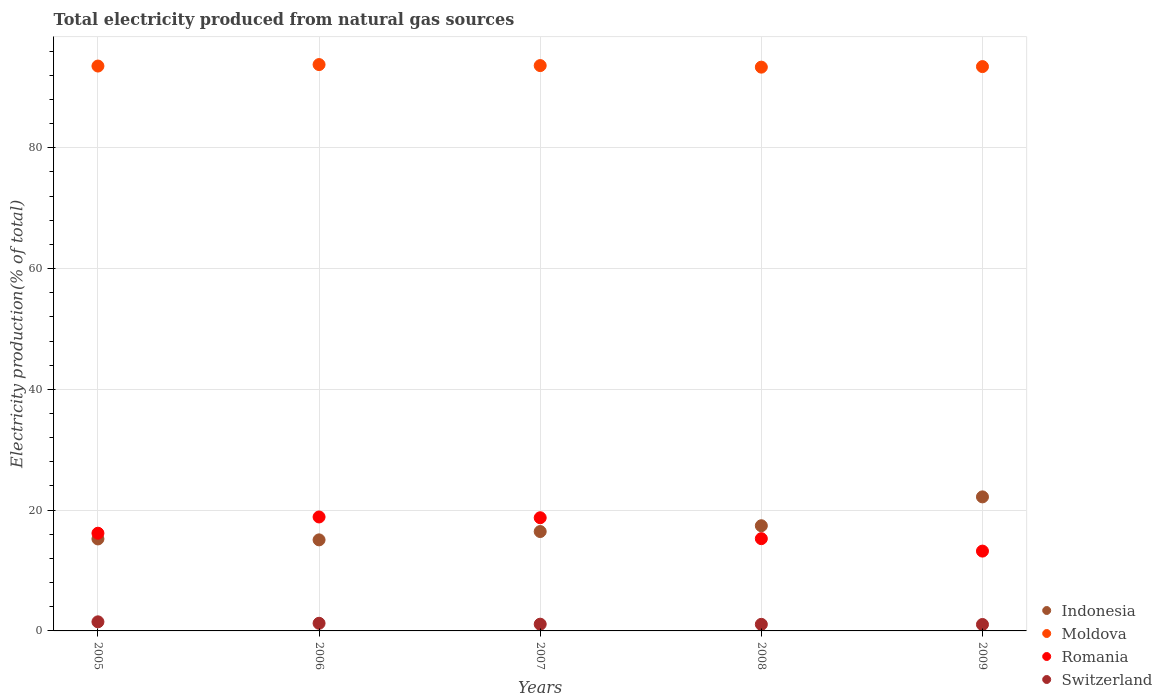What is the total electricity produced in Indonesia in 2005?
Keep it short and to the point. 15.23. Across all years, what is the maximum total electricity produced in Indonesia?
Keep it short and to the point. 22.2. Across all years, what is the minimum total electricity produced in Moldova?
Offer a terse response. 93.36. What is the total total electricity produced in Moldova in the graph?
Give a very brief answer. 467.75. What is the difference between the total electricity produced in Moldova in 2007 and that in 2009?
Ensure brevity in your answer.  0.17. What is the difference between the total electricity produced in Indonesia in 2009 and the total electricity produced in Switzerland in 2007?
Ensure brevity in your answer.  21.08. What is the average total electricity produced in Moldova per year?
Keep it short and to the point. 93.55. In the year 2007, what is the difference between the total electricity produced in Indonesia and total electricity produced in Romania?
Make the answer very short. -2.29. What is the ratio of the total electricity produced in Romania in 2005 to that in 2008?
Provide a succinct answer. 1.06. Is the total electricity produced in Indonesia in 2006 less than that in 2009?
Ensure brevity in your answer.  Yes. Is the difference between the total electricity produced in Indonesia in 2005 and 2007 greater than the difference between the total electricity produced in Romania in 2005 and 2007?
Offer a terse response. Yes. What is the difference between the highest and the second highest total electricity produced in Indonesia?
Offer a very short reply. 4.78. What is the difference between the highest and the lowest total electricity produced in Switzerland?
Your answer should be very brief. 0.44. In how many years, is the total electricity produced in Romania greater than the average total electricity produced in Romania taken over all years?
Provide a short and direct response. 2. Is the sum of the total electricity produced in Moldova in 2005 and 2007 greater than the maximum total electricity produced in Switzerland across all years?
Provide a succinct answer. Yes. Is it the case that in every year, the sum of the total electricity produced in Romania and total electricity produced in Indonesia  is greater than the sum of total electricity produced in Switzerland and total electricity produced in Moldova?
Keep it short and to the point. No. Does the total electricity produced in Romania monotonically increase over the years?
Your answer should be compact. No. Is the total electricity produced in Indonesia strictly greater than the total electricity produced in Moldova over the years?
Offer a terse response. No. How many years are there in the graph?
Give a very brief answer. 5. What is the difference between two consecutive major ticks on the Y-axis?
Provide a succinct answer. 20. Are the values on the major ticks of Y-axis written in scientific E-notation?
Offer a terse response. No. How many legend labels are there?
Offer a very short reply. 4. What is the title of the graph?
Your answer should be compact. Total electricity produced from natural gas sources. What is the Electricity production(% of total) in Indonesia in 2005?
Your answer should be compact. 15.23. What is the Electricity production(% of total) of Moldova in 2005?
Provide a short and direct response. 93.54. What is the Electricity production(% of total) of Romania in 2005?
Your response must be concise. 16.18. What is the Electricity production(% of total) in Switzerland in 2005?
Ensure brevity in your answer.  1.51. What is the Electricity production(% of total) in Indonesia in 2006?
Provide a short and direct response. 15.08. What is the Electricity production(% of total) in Moldova in 2006?
Your answer should be very brief. 93.78. What is the Electricity production(% of total) in Romania in 2006?
Your response must be concise. 18.87. What is the Electricity production(% of total) in Switzerland in 2006?
Ensure brevity in your answer.  1.26. What is the Electricity production(% of total) in Indonesia in 2007?
Make the answer very short. 16.46. What is the Electricity production(% of total) in Moldova in 2007?
Your answer should be very brief. 93.62. What is the Electricity production(% of total) of Romania in 2007?
Your response must be concise. 18.74. What is the Electricity production(% of total) of Switzerland in 2007?
Offer a very short reply. 1.12. What is the Electricity production(% of total) in Indonesia in 2008?
Provide a short and direct response. 17.42. What is the Electricity production(% of total) in Moldova in 2008?
Give a very brief answer. 93.36. What is the Electricity production(% of total) in Romania in 2008?
Your answer should be compact. 15.28. What is the Electricity production(% of total) in Switzerland in 2008?
Provide a short and direct response. 1.09. What is the Electricity production(% of total) in Indonesia in 2009?
Ensure brevity in your answer.  22.2. What is the Electricity production(% of total) of Moldova in 2009?
Give a very brief answer. 93.45. What is the Electricity production(% of total) in Romania in 2009?
Your response must be concise. 13.22. What is the Electricity production(% of total) of Switzerland in 2009?
Give a very brief answer. 1.06. Across all years, what is the maximum Electricity production(% of total) in Indonesia?
Your answer should be very brief. 22.2. Across all years, what is the maximum Electricity production(% of total) of Moldova?
Provide a succinct answer. 93.78. Across all years, what is the maximum Electricity production(% of total) of Romania?
Offer a terse response. 18.87. Across all years, what is the maximum Electricity production(% of total) in Switzerland?
Your response must be concise. 1.51. Across all years, what is the minimum Electricity production(% of total) of Indonesia?
Provide a short and direct response. 15.08. Across all years, what is the minimum Electricity production(% of total) in Moldova?
Offer a very short reply. 93.36. Across all years, what is the minimum Electricity production(% of total) of Romania?
Provide a short and direct response. 13.22. Across all years, what is the minimum Electricity production(% of total) in Switzerland?
Offer a terse response. 1.06. What is the total Electricity production(% of total) of Indonesia in the graph?
Your answer should be very brief. 86.38. What is the total Electricity production(% of total) in Moldova in the graph?
Provide a short and direct response. 467.75. What is the total Electricity production(% of total) in Romania in the graph?
Make the answer very short. 82.29. What is the total Electricity production(% of total) in Switzerland in the graph?
Offer a very short reply. 6.04. What is the difference between the Electricity production(% of total) in Indonesia in 2005 and that in 2006?
Your answer should be compact. 0.16. What is the difference between the Electricity production(% of total) of Moldova in 2005 and that in 2006?
Keep it short and to the point. -0.24. What is the difference between the Electricity production(% of total) in Romania in 2005 and that in 2006?
Offer a terse response. -2.69. What is the difference between the Electricity production(% of total) of Switzerland in 2005 and that in 2006?
Your response must be concise. 0.24. What is the difference between the Electricity production(% of total) in Indonesia in 2005 and that in 2007?
Your answer should be very brief. -1.22. What is the difference between the Electricity production(% of total) of Moldova in 2005 and that in 2007?
Provide a short and direct response. -0.08. What is the difference between the Electricity production(% of total) of Romania in 2005 and that in 2007?
Offer a very short reply. -2.56. What is the difference between the Electricity production(% of total) in Switzerland in 2005 and that in 2007?
Your answer should be very brief. 0.39. What is the difference between the Electricity production(% of total) in Indonesia in 2005 and that in 2008?
Make the answer very short. -2.18. What is the difference between the Electricity production(% of total) of Moldova in 2005 and that in 2008?
Offer a very short reply. 0.18. What is the difference between the Electricity production(% of total) of Romania in 2005 and that in 2008?
Keep it short and to the point. 0.9. What is the difference between the Electricity production(% of total) of Switzerland in 2005 and that in 2008?
Provide a succinct answer. 0.42. What is the difference between the Electricity production(% of total) in Indonesia in 2005 and that in 2009?
Provide a succinct answer. -6.96. What is the difference between the Electricity production(% of total) in Moldova in 2005 and that in 2009?
Your answer should be very brief. 0.09. What is the difference between the Electricity production(% of total) in Romania in 2005 and that in 2009?
Offer a very short reply. 2.96. What is the difference between the Electricity production(% of total) in Switzerland in 2005 and that in 2009?
Make the answer very short. 0.44. What is the difference between the Electricity production(% of total) in Indonesia in 2006 and that in 2007?
Provide a short and direct response. -1.38. What is the difference between the Electricity production(% of total) of Moldova in 2006 and that in 2007?
Your answer should be compact. 0.17. What is the difference between the Electricity production(% of total) in Romania in 2006 and that in 2007?
Provide a short and direct response. 0.13. What is the difference between the Electricity production(% of total) of Switzerland in 2006 and that in 2007?
Provide a short and direct response. 0.15. What is the difference between the Electricity production(% of total) of Indonesia in 2006 and that in 2008?
Make the answer very short. -2.34. What is the difference between the Electricity production(% of total) of Moldova in 2006 and that in 2008?
Keep it short and to the point. 0.43. What is the difference between the Electricity production(% of total) in Romania in 2006 and that in 2008?
Offer a terse response. 3.59. What is the difference between the Electricity production(% of total) of Switzerland in 2006 and that in 2008?
Keep it short and to the point. 0.17. What is the difference between the Electricity production(% of total) of Indonesia in 2006 and that in 2009?
Your answer should be very brief. -7.12. What is the difference between the Electricity production(% of total) in Moldova in 2006 and that in 2009?
Make the answer very short. 0.33. What is the difference between the Electricity production(% of total) of Romania in 2006 and that in 2009?
Your answer should be compact. 5.65. What is the difference between the Electricity production(% of total) of Switzerland in 2006 and that in 2009?
Your response must be concise. 0.2. What is the difference between the Electricity production(% of total) of Indonesia in 2007 and that in 2008?
Your answer should be compact. -0.96. What is the difference between the Electricity production(% of total) of Moldova in 2007 and that in 2008?
Your answer should be very brief. 0.26. What is the difference between the Electricity production(% of total) in Romania in 2007 and that in 2008?
Ensure brevity in your answer.  3.46. What is the difference between the Electricity production(% of total) in Switzerland in 2007 and that in 2008?
Your response must be concise. 0.03. What is the difference between the Electricity production(% of total) of Indonesia in 2007 and that in 2009?
Make the answer very short. -5.74. What is the difference between the Electricity production(% of total) in Moldova in 2007 and that in 2009?
Provide a short and direct response. 0.17. What is the difference between the Electricity production(% of total) of Romania in 2007 and that in 2009?
Provide a short and direct response. 5.52. What is the difference between the Electricity production(% of total) in Switzerland in 2007 and that in 2009?
Your answer should be very brief. 0.05. What is the difference between the Electricity production(% of total) in Indonesia in 2008 and that in 2009?
Offer a terse response. -4.78. What is the difference between the Electricity production(% of total) in Moldova in 2008 and that in 2009?
Offer a terse response. -0.09. What is the difference between the Electricity production(% of total) in Romania in 2008 and that in 2009?
Offer a terse response. 2.06. What is the difference between the Electricity production(% of total) in Switzerland in 2008 and that in 2009?
Give a very brief answer. 0.02. What is the difference between the Electricity production(% of total) in Indonesia in 2005 and the Electricity production(% of total) in Moldova in 2006?
Your response must be concise. -78.55. What is the difference between the Electricity production(% of total) in Indonesia in 2005 and the Electricity production(% of total) in Romania in 2006?
Your response must be concise. -3.64. What is the difference between the Electricity production(% of total) in Indonesia in 2005 and the Electricity production(% of total) in Switzerland in 2006?
Your response must be concise. 13.97. What is the difference between the Electricity production(% of total) of Moldova in 2005 and the Electricity production(% of total) of Romania in 2006?
Offer a terse response. 74.67. What is the difference between the Electricity production(% of total) of Moldova in 2005 and the Electricity production(% of total) of Switzerland in 2006?
Ensure brevity in your answer.  92.28. What is the difference between the Electricity production(% of total) of Romania in 2005 and the Electricity production(% of total) of Switzerland in 2006?
Ensure brevity in your answer.  14.91. What is the difference between the Electricity production(% of total) in Indonesia in 2005 and the Electricity production(% of total) in Moldova in 2007?
Your answer should be very brief. -78.38. What is the difference between the Electricity production(% of total) in Indonesia in 2005 and the Electricity production(% of total) in Romania in 2007?
Offer a very short reply. -3.51. What is the difference between the Electricity production(% of total) in Indonesia in 2005 and the Electricity production(% of total) in Switzerland in 2007?
Offer a terse response. 14.12. What is the difference between the Electricity production(% of total) of Moldova in 2005 and the Electricity production(% of total) of Romania in 2007?
Your answer should be compact. 74.8. What is the difference between the Electricity production(% of total) of Moldova in 2005 and the Electricity production(% of total) of Switzerland in 2007?
Offer a terse response. 92.42. What is the difference between the Electricity production(% of total) in Romania in 2005 and the Electricity production(% of total) in Switzerland in 2007?
Keep it short and to the point. 15.06. What is the difference between the Electricity production(% of total) in Indonesia in 2005 and the Electricity production(% of total) in Moldova in 2008?
Keep it short and to the point. -78.12. What is the difference between the Electricity production(% of total) in Indonesia in 2005 and the Electricity production(% of total) in Romania in 2008?
Your answer should be compact. -0.05. What is the difference between the Electricity production(% of total) in Indonesia in 2005 and the Electricity production(% of total) in Switzerland in 2008?
Give a very brief answer. 14.14. What is the difference between the Electricity production(% of total) in Moldova in 2005 and the Electricity production(% of total) in Romania in 2008?
Your answer should be compact. 78.26. What is the difference between the Electricity production(% of total) in Moldova in 2005 and the Electricity production(% of total) in Switzerland in 2008?
Keep it short and to the point. 92.45. What is the difference between the Electricity production(% of total) of Romania in 2005 and the Electricity production(% of total) of Switzerland in 2008?
Keep it short and to the point. 15.09. What is the difference between the Electricity production(% of total) in Indonesia in 2005 and the Electricity production(% of total) in Moldova in 2009?
Keep it short and to the point. -78.22. What is the difference between the Electricity production(% of total) in Indonesia in 2005 and the Electricity production(% of total) in Romania in 2009?
Provide a short and direct response. 2.02. What is the difference between the Electricity production(% of total) of Indonesia in 2005 and the Electricity production(% of total) of Switzerland in 2009?
Provide a succinct answer. 14.17. What is the difference between the Electricity production(% of total) in Moldova in 2005 and the Electricity production(% of total) in Romania in 2009?
Provide a short and direct response. 80.32. What is the difference between the Electricity production(% of total) of Moldova in 2005 and the Electricity production(% of total) of Switzerland in 2009?
Offer a terse response. 92.47. What is the difference between the Electricity production(% of total) of Romania in 2005 and the Electricity production(% of total) of Switzerland in 2009?
Offer a terse response. 15.11. What is the difference between the Electricity production(% of total) of Indonesia in 2006 and the Electricity production(% of total) of Moldova in 2007?
Your response must be concise. -78.54. What is the difference between the Electricity production(% of total) in Indonesia in 2006 and the Electricity production(% of total) in Romania in 2007?
Make the answer very short. -3.66. What is the difference between the Electricity production(% of total) of Indonesia in 2006 and the Electricity production(% of total) of Switzerland in 2007?
Offer a terse response. 13.96. What is the difference between the Electricity production(% of total) in Moldova in 2006 and the Electricity production(% of total) in Romania in 2007?
Ensure brevity in your answer.  75.04. What is the difference between the Electricity production(% of total) of Moldova in 2006 and the Electricity production(% of total) of Switzerland in 2007?
Offer a terse response. 92.67. What is the difference between the Electricity production(% of total) of Romania in 2006 and the Electricity production(% of total) of Switzerland in 2007?
Your response must be concise. 17.75. What is the difference between the Electricity production(% of total) in Indonesia in 2006 and the Electricity production(% of total) in Moldova in 2008?
Provide a short and direct response. -78.28. What is the difference between the Electricity production(% of total) in Indonesia in 2006 and the Electricity production(% of total) in Romania in 2008?
Keep it short and to the point. -0.2. What is the difference between the Electricity production(% of total) in Indonesia in 2006 and the Electricity production(% of total) in Switzerland in 2008?
Ensure brevity in your answer.  13.99. What is the difference between the Electricity production(% of total) of Moldova in 2006 and the Electricity production(% of total) of Romania in 2008?
Provide a short and direct response. 78.51. What is the difference between the Electricity production(% of total) in Moldova in 2006 and the Electricity production(% of total) in Switzerland in 2008?
Your answer should be very brief. 92.69. What is the difference between the Electricity production(% of total) in Romania in 2006 and the Electricity production(% of total) in Switzerland in 2008?
Keep it short and to the point. 17.78. What is the difference between the Electricity production(% of total) of Indonesia in 2006 and the Electricity production(% of total) of Moldova in 2009?
Make the answer very short. -78.37. What is the difference between the Electricity production(% of total) of Indonesia in 2006 and the Electricity production(% of total) of Romania in 2009?
Offer a terse response. 1.86. What is the difference between the Electricity production(% of total) of Indonesia in 2006 and the Electricity production(% of total) of Switzerland in 2009?
Provide a short and direct response. 14.01. What is the difference between the Electricity production(% of total) of Moldova in 2006 and the Electricity production(% of total) of Romania in 2009?
Your answer should be very brief. 80.57. What is the difference between the Electricity production(% of total) of Moldova in 2006 and the Electricity production(% of total) of Switzerland in 2009?
Keep it short and to the point. 92.72. What is the difference between the Electricity production(% of total) in Romania in 2006 and the Electricity production(% of total) in Switzerland in 2009?
Make the answer very short. 17.81. What is the difference between the Electricity production(% of total) in Indonesia in 2007 and the Electricity production(% of total) in Moldova in 2008?
Offer a terse response. -76.9. What is the difference between the Electricity production(% of total) in Indonesia in 2007 and the Electricity production(% of total) in Romania in 2008?
Give a very brief answer. 1.18. What is the difference between the Electricity production(% of total) of Indonesia in 2007 and the Electricity production(% of total) of Switzerland in 2008?
Make the answer very short. 15.37. What is the difference between the Electricity production(% of total) of Moldova in 2007 and the Electricity production(% of total) of Romania in 2008?
Make the answer very short. 78.34. What is the difference between the Electricity production(% of total) in Moldova in 2007 and the Electricity production(% of total) in Switzerland in 2008?
Offer a very short reply. 92.53. What is the difference between the Electricity production(% of total) of Romania in 2007 and the Electricity production(% of total) of Switzerland in 2008?
Offer a very short reply. 17.65. What is the difference between the Electricity production(% of total) of Indonesia in 2007 and the Electricity production(% of total) of Moldova in 2009?
Keep it short and to the point. -76.99. What is the difference between the Electricity production(% of total) in Indonesia in 2007 and the Electricity production(% of total) in Romania in 2009?
Offer a terse response. 3.24. What is the difference between the Electricity production(% of total) in Indonesia in 2007 and the Electricity production(% of total) in Switzerland in 2009?
Make the answer very short. 15.39. What is the difference between the Electricity production(% of total) in Moldova in 2007 and the Electricity production(% of total) in Romania in 2009?
Make the answer very short. 80.4. What is the difference between the Electricity production(% of total) in Moldova in 2007 and the Electricity production(% of total) in Switzerland in 2009?
Ensure brevity in your answer.  92.55. What is the difference between the Electricity production(% of total) in Romania in 2007 and the Electricity production(% of total) in Switzerland in 2009?
Give a very brief answer. 17.68. What is the difference between the Electricity production(% of total) of Indonesia in 2008 and the Electricity production(% of total) of Moldova in 2009?
Offer a very short reply. -76.03. What is the difference between the Electricity production(% of total) of Indonesia in 2008 and the Electricity production(% of total) of Romania in 2009?
Provide a succinct answer. 4.2. What is the difference between the Electricity production(% of total) in Indonesia in 2008 and the Electricity production(% of total) in Switzerland in 2009?
Make the answer very short. 16.35. What is the difference between the Electricity production(% of total) in Moldova in 2008 and the Electricity production(% of total) in Romania in 2009?
Offer a terse response. 80.14. What is the difference between the Electricity production(% of total) in Moldova in 2008 and the Electricity production(% of total) in Switzerland in 2009?
Your answer should be very brief. 92.29. What is the difference between the Electricity production(% of total) in Romania in 2008 and the Electricity production(% of total) in Switzerland in 2009?
Give a very brief answer. 14.21. What is the average Electricity production(% of total) in Indonesia per year?
Provide a succinct answer. 17.28. What is the average Electricity production(% of total) in Moldova per year?
Offer a terse response. 93.55. What is the average Electricity production(% of total) of Romania per year?
Make the answer very short. 16.46. What is the average Electricity production(% of total) in Switzerland per year?
Your answer should be very brief. 1.21. In the year 2005, what is the difference between the Electricity production(% of total) of Indonesia and Electricity production(% of total) of Moldova?
Keep it short and to the point. -78.31. In the year 2005, what is the difference between the Electricity production(% of total) of Indonesia and Electricity production(% of total) of Romania?
Your answer should be very brief. -0.95. In the year 2005, what is the difference between the Electricity production(% of total) in Indonesia and Electricity production(% of total) in Switzerland?
Provide a succinct answer. 13.73. In the year 2005, what is the difference between the Electricity production(% of total) of Moldova and Electricity production(% of total) of Romania?
Offer a very short reply. 77.36. In the year 2005, what is the difference between the Electricity production(% of total) of Moldova and Electricity production(% of total) of Switzerland?
Keep it short and to the point. 92.03. In the year 2005, what is the difference between the Electricity production(% of total) of Romania and Electricity production(% of total) of Switzerland?
Ensure brevity in your answer.  14.67. In the year 2006, what is the difference between the Electricity production(% of total) in Indonesia and Electricity production(% of total) in Moldova?
Make the answer very short. -78.71. In the year 2006, what is the difference between the Electricity production(% of total) of Indonesia and Electricity production(% of total) of Romania?
Your response must be concise. -3.79. In the year 2006, what is the difference between the Electricity production(% of total) of Indonesia and Electricity production(% of total) of Switzerland?
Make the answer very short. 13.81. In the year 2006, what is the difference between the Electricity production(% of total) of Moldova and Electricity production(% of total) of Romania?
Provide a short and direct response. 74.91. In the year 2006, what is the difference between the Electricity production(% of total) of Moldova and Electricity production(% of total) of Switzerland?
Offer a terse response. 92.52. In the year 2006, what is the difference between the Electricity production(% of total) in Romania and Electricity production(% of total) in Switzerland?
Offer a very short reply. 17.61. In the year 2007, what is the difference between the Electricity production(% of total) of Indonesia and Electricity production(% of total) of Moldova?
Offer a terse response. -77.16. In the year 2007, what is the difference between the Electricity production(% of total) in Indonesia and Electricity production(% of total) in Romania?
Offer a very short reply. -2.29. In the year 2007, what is the difference between the Electricity production(% of total) in Indonesia and Electricity production(% of total) in Switzerland?
Your answer should be compact. 15.34. In the year 2007, what is the difference between the Electricity production(% of total) in Moldova and Electricity production(% of total) in Romania?
Your answer should be compact. 74.87. In the year 2007, what is the difference between the Electricity production(% of total) of Moldova and Electricity production(% of total) of Switzerland?
Provide a short and direct response. 92.5. In the year 2007, what is the difference between the Electricity production(% of total) in Romania and Electricity production(% of total) in Switzerland?
Provide a succinct answer. 17.63. In the year 2008, what is the difference between the Electricity production(% of total) in Indonesia and Electricity production(% of total) in Moldova?
Your answer should be compact. -75.94. In the year 2008, what is the difference between the Electricity production(% of total) in Indonesia and Electricity production(% of total) in Romania?
Make the answer very short. 2.14. In the year 2008, what is the difference between the Electricity production(% of total) in Indonesia and Electricity production(% of total) in Switzerland?
Ensure brevity in your answer.  16.33. In the year 2008, what is the difference between the Electricity production(% of total) in Moldova and Electricity production(% of total) in Romania?
Provide a succinct answer. 78.08. In the year 2008, what is the difference between the Electricity production(% of total) in Moldova and Electricity production(% of total) in Switzerland?
Offer a terse response. 92.27. In the year 2008, what is the difference between the Electricity production(% of total) of Romania and Electricity production(% of total) of Switzerland?
Provide a succinct answer. 14.19. In the year 2009, what is the difference between the Electricity production(% of total) of Indonesia and Electricity production(% of total) of Moldova?
Your response must be concise. -71.25. In the year 2009, what is the difference between the Electricity production(% of total) of Indonesia and Electricity production(% of total) of Romania?
Your response must be concise. 8.98. In the year 2009, what is the difference between the Electricity production(% of total) of Indonesia and Electricity production(% of total) of Switzerland?
Provide a short and direct response. 21.13. In the year 2009, what is the difference between the Electricity production(% of total) in Moldova and Electricity production(% of total) in Romania?
Provide a short and direct response. 80.23. In the year 2009, what is the difference between the Electricity production(% of total) in Moldova and Electricity production(% of total) in Switzerland?
Ensure brevity in your answer.  92.38. In the year 2009, what is the difference between the Electricity production(% of total) in Romania and Electricity production(% of total) in Switzerland?
Give a very brief answer. 12.15. What is the ratio of the Electricity production(% of total) of Indonesia in 2005 to that in 2006?
Your answer should be very brief. 1.01. What is the ratio of the Electricity production(% of total) in Moldova in 2005 to that in 2006?
Ensure brevity in your answer.  1. What is the ratio of the Electricity production(% of total) in Romania in 2005 to that in 2006?
Offer a very short reply. 0.86. What is the ratio of the Electricity production(% of total) in Switzerland in 2005 to that in 2006?
Ensure brevity in your answer.  1.19. What is the ratio of the Electricity production(% of total) in Indonesia in 2005 to that in 2007?
Provide a short and direct response. 0.93. What is the ratio of the Electricity production(% of total) of Romania in 2005 to that in 2007?
Give a very brief answer. 0.86. What is the ratio of the Electricity production(% of total) in Switzerland in 2005 to that in 2007?
Make the answer very short. 1.35. What is the ratio of the Electricity production(% of total) of Indonesia in 2005 to that in 2008?
Offer a terse response. 0.87. What is the ratio of the Electricity production(% of total) in Moldova in 2005 to that in 2008?
Offer a terse response. 1. What is the ratio of the Electricity production(% of total) of Romania in 2005 to that in 2008?
Your response must be concise. 1.06. What is the ratio of the Electricity production(% of total) in Switzerland in 2005 to that in 2008?
Your answer should be very brief. 1.38. What is the ratio of the Electricity production(% of total) in Indonesia in 2005 to that in 2009?
Provide a succinct answer. 0.69. What is the ratio of the Electricity production(% of total) in Moldova in 2005 to that in 2009?
Provide a short and direct response. 1. What is the ratio of the Electricity production(% of total) of Romania in 2005 to that in 2009?
Your answer should be compact. 1.22. What is the ratio of the Electricity production(% of total) of Switzerland in 2005 to that in 2009?
Your response must be concise. 1.41. What is the ratio of the Electricity production(% of total) of Indonesia in 2006 to that in 2007?
Your answer should be compact. 0.92. What is the ratio of the Electricity production(% of total) in Moldova in 2006 to that in 2007?
Provide a short and direct response. 1. What is the ratio of the Electricity production(% of total) in Romania in 2006 to that in 2007?
Provide a short and direct response. 1.01. What is the ratio of the Electricity production(% of total) in Switzerland in 2006 to that in 2007?
Your answer should be very brief. 1.13. What is the ratio of the Electricity production(% of total) of Indonesia in 2006 to that in 2008?
Offer a terse response. 0.87. What is the ratio of the Electricity production(% of total) in Moldova in 2006 to that in 2008?
Offer a very short reply. 1. What is the ratio of the Electricity production(% of total) in Romania in 2006 to that in 2008?
Provide a short and direct response. 1.24. What is the ratio of the Electricity production(% of total) in Switzerland in 2006 to that in 2008?
Make the answer very short. 1.16. What is the ratio of the Electricity production(% of total) of Indonesia in 2006 to that in 2009?
Your answer should be compact. 0.68. What is the ratio of the Electricity production(% of total) in Romania in 2006 to that in 2009?
Your answer should be very brief. 1.43. What is the ratio of the Electricity production(% of total) in Switzerland in 2006 to that in 2009?
Keep it short and to the point. 1.19. What is the ratio of the Electricity production(% of total) in Indonesia in 2007 to that in 2008?
Make the answer very short. 0.94. What is the ratio of the Electricity production(% of total) of Romania in 2007 to that in 2008?
Your response must be concise. 1.23. What is the ratio of the Electricity production(% of total) of Switzerland in 2007 to that in 2008?
Offer a very short reply. 1.02. What is the ratio of the Electricity production(% of total) in Indonesia in 2007 to that in 2009?
Provide a short and direct response. 0.74. What is the ratio of the Electricity production(% of total) in Romania in 2007 to that in 2009?
Your answer should be very brief. 1.42. What is the ratio of the Electricity production(% of total) in Switzerland in 2007 to that in 2009?
Offer a terse response. 1.05. What is the ratio of the Electricity production(% of total) of Indonesia in 2008 to that in 2009?
Your response must be concise. 0.78. What is the ratio of the Electricity production(% of total) of Moldova in 2008 to that in 2009?
Your answer should be compact. 1. What is the ratio of the Electricity production(% of total) of Romania in 2008 to that in 2009?
Make the answer very short. 1.16. What is the ratio of the Electricity production(% of total) in Switzerland in 2008 to that in 2009?
Your response must be concise. 1.02. What is the difference between the highest and the second highest Electricity production(% of total) of Indonesia?
Make the answer very short. 4.78. What is the difference between the highest and the second highest Electricity production(% of total) in Moldova?
Make the answer very short. 0.17. What is the difference between the highest and the second highest Electricity production(% of total) in Romania?
Your answer should be very brief. 0.13. What is the difference between the highest and the second highest Electricity production(% of total) in Switzerland?
Keep it short and to the point. 0.24. What is the difference between the highest and the lowest Electricity production(% of total) in Indonesia?
Provide a succinct answer. 7.12. What is the difference between the highest and the lowest Electricity production(% of total) of Moldova?
Keep it short and to the point. 0.43. What is the difference between the highest and the lowest Electricity production(% of total) in Romania?
Your answer should be compact. 5.65. What is the difference between the highest and the lowest Electricity production(% of total) of Switzerland?
Your response must be concise. 0.44. 